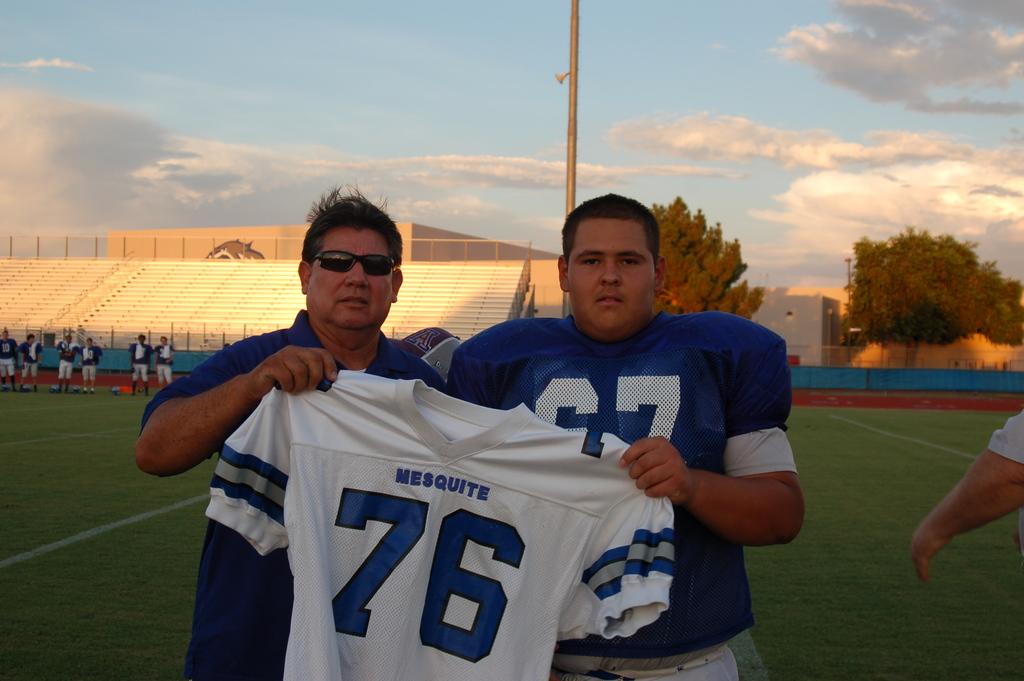What is the number on the white jersey?
Make the answer very short. 76. 